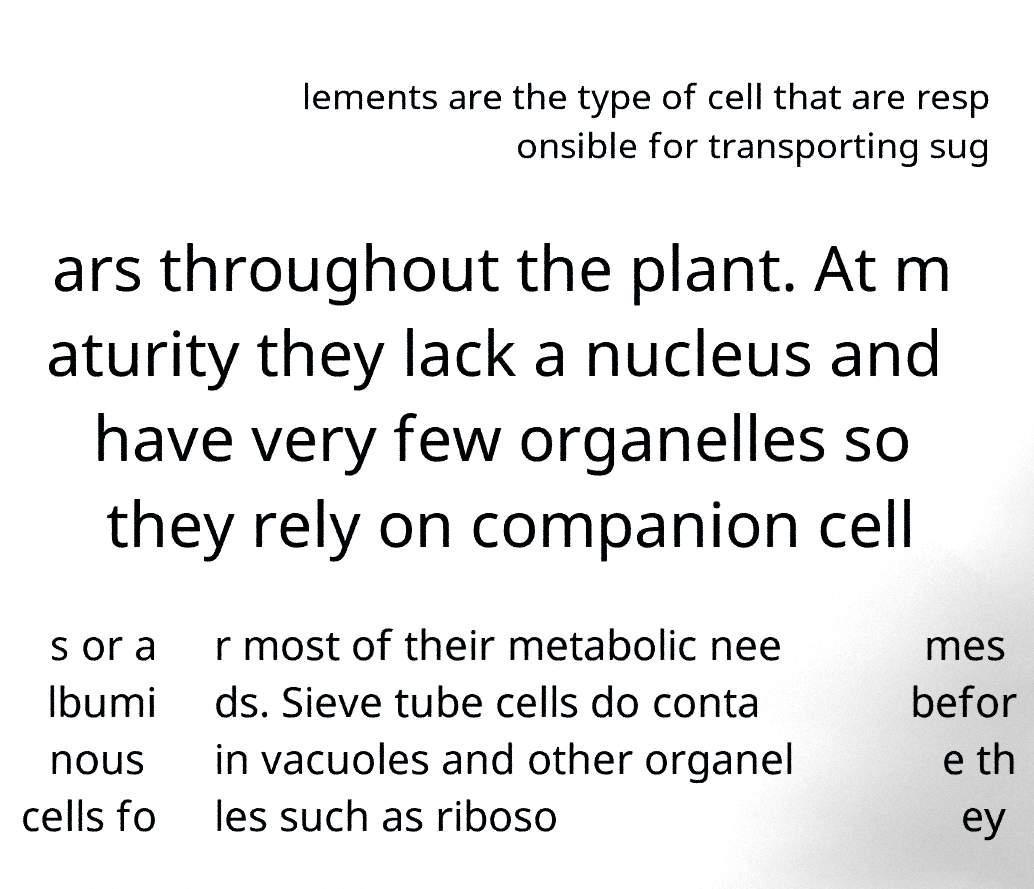There's text embedded in this image that I need extracted. Can you transcribe it verbatim? lements are the type of cell that are resp onsible for transporting sug ars throughout the plant. At m aturity they lack a nucleus and have very few organelles so they rely on companion cell s or a lbumi nous cells fo r most of their metabolic nee ds. Sieve tube cells do conta in vacuoles and other organel les such as riboso mes befor e th ey 